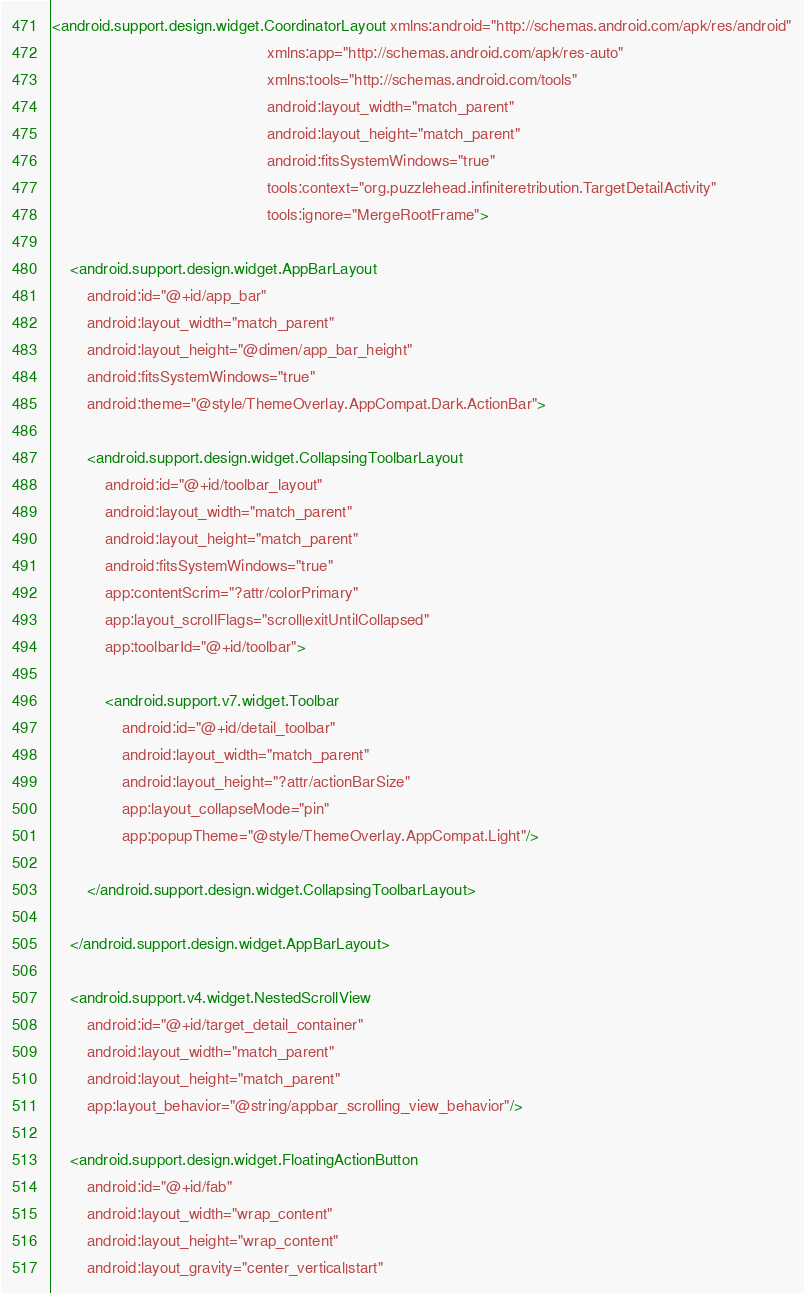<code> <loc_0><loc_0><loc_500><loc_500><_XML_><android.support.design.widget.CoordinatorLayout xmlns:android="http://schemas.android.com/apk/res/android"
                                                 xmlns:app="http://schemas.android.com/apk/res-auto"
                                                 xmlns:tools="http://schemas.android.com/tools"
                                                 android:layout_width="match_parent"
                                                 android:layout_height="match_parent"
                                                 android:fitsSystemWindows="true"
                                                 tools:context="org.puzzlehead.infiniteretribution.TargetDetailActivity"
                                                 tools:ignore="MergeRootFrame">

    <android.support.design.widget.AppBarLayout
        android:id="@+id/app_bar"
        android:layout_width="match_parent"
        android:layout_height="@dimen/app_bar_height"
        android:fitsSystemWindows="true"
        android:theme="@style/ThemeOverlay.AppCompat.Dark.ActionBar">

        <android.support.design.widget.CollapsingToolbarLayout
            android:id="@+id/toolbar_layout"
            android:layout_width="match_parent"
            android:layout_height="match_parent"
            android:fitsSystemWindows="true"
            app:contentScrim="?attr/colorPrimary"
            app:layout_scrollFlags="scroll|exitUntilCollapsed"
            app:toolbarId="@+id/toolbar">

            <android.support.v7.widget.Toolbar
                android:id="@+id/detail_toolbar"
                android:layout_width="match_parent"
                android:layout_height="?attr/actionBarSize"
                app:layout_collapseMode="pin"
                app:popupTheme="@style/ThemeOverlay.AppCompat.Light"/>

        </android.support.design.widget.CollapsingToolbarLayout>

    </android.support.design.widget.AppBarLayout>

    <android.support.v4.widget.NestedScrollView
        android:id="@+id/target_detail_container"
        android:layout_width="match_parent"
        android:layout_height="match_parent"
        app:layout_behavior="@string/appbar_scrolling_view_behavior"/>

    <android.support.design.widget.FloatingActionButton
        android:id="@+id/fab"
        android:layout_width="wrap_content"
        android:layout_height="wrap_content"
        android:layout_gravity="center_vertical|start"</code> 